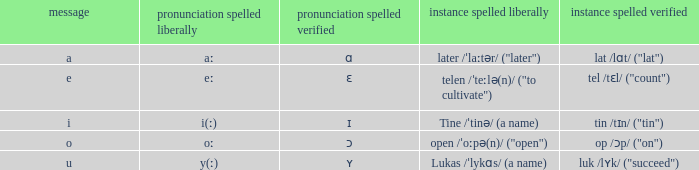What is Pronunciation Spelled Free, when Pronunciation Spelled Checked is "ʏ"? Y(ː). 